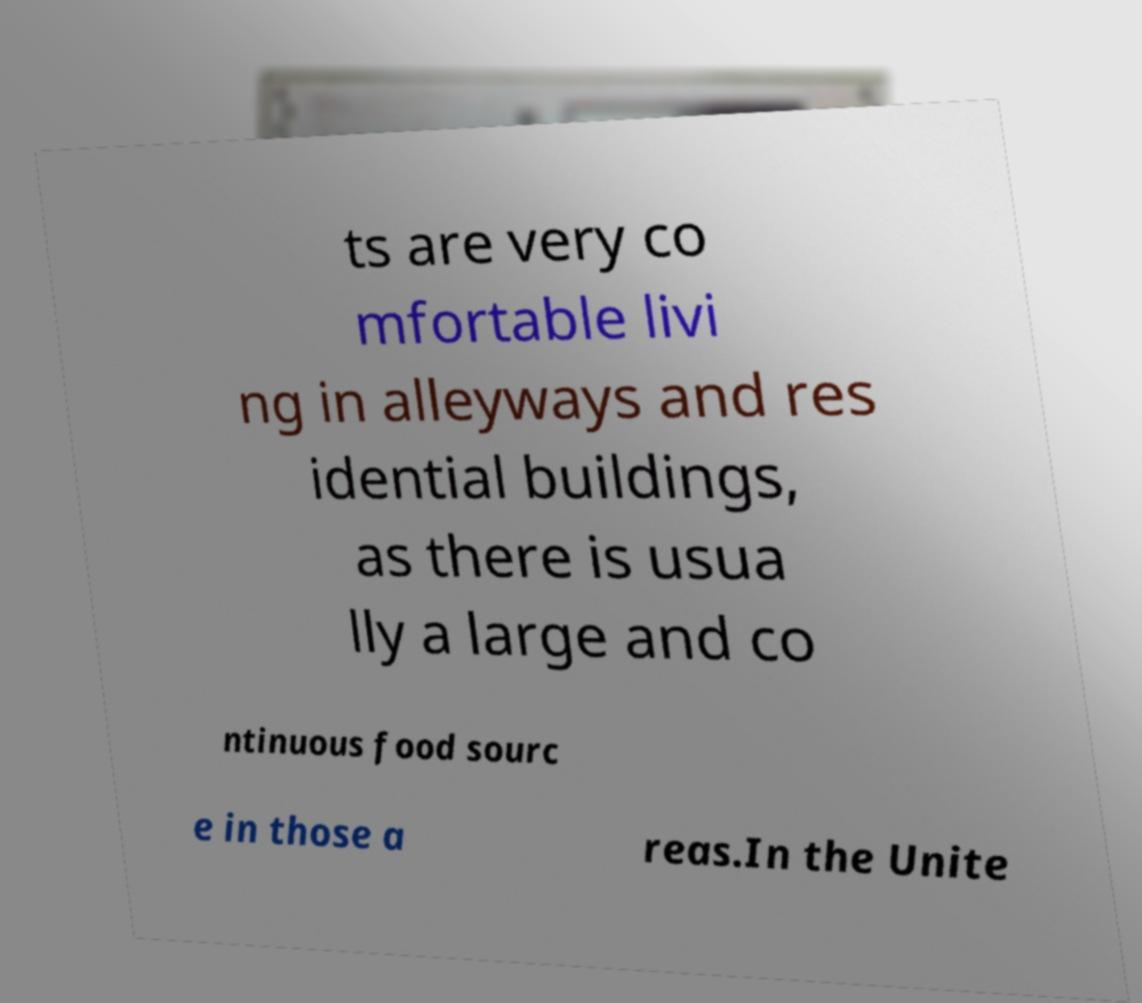Can you accurately transcribe the text from the provided image for me? ts are very co mfortable livi ng in alleyways and res idential buildings, as there is usua lly a large and co ntinuous food sourc e in those a reas.In the Unite 